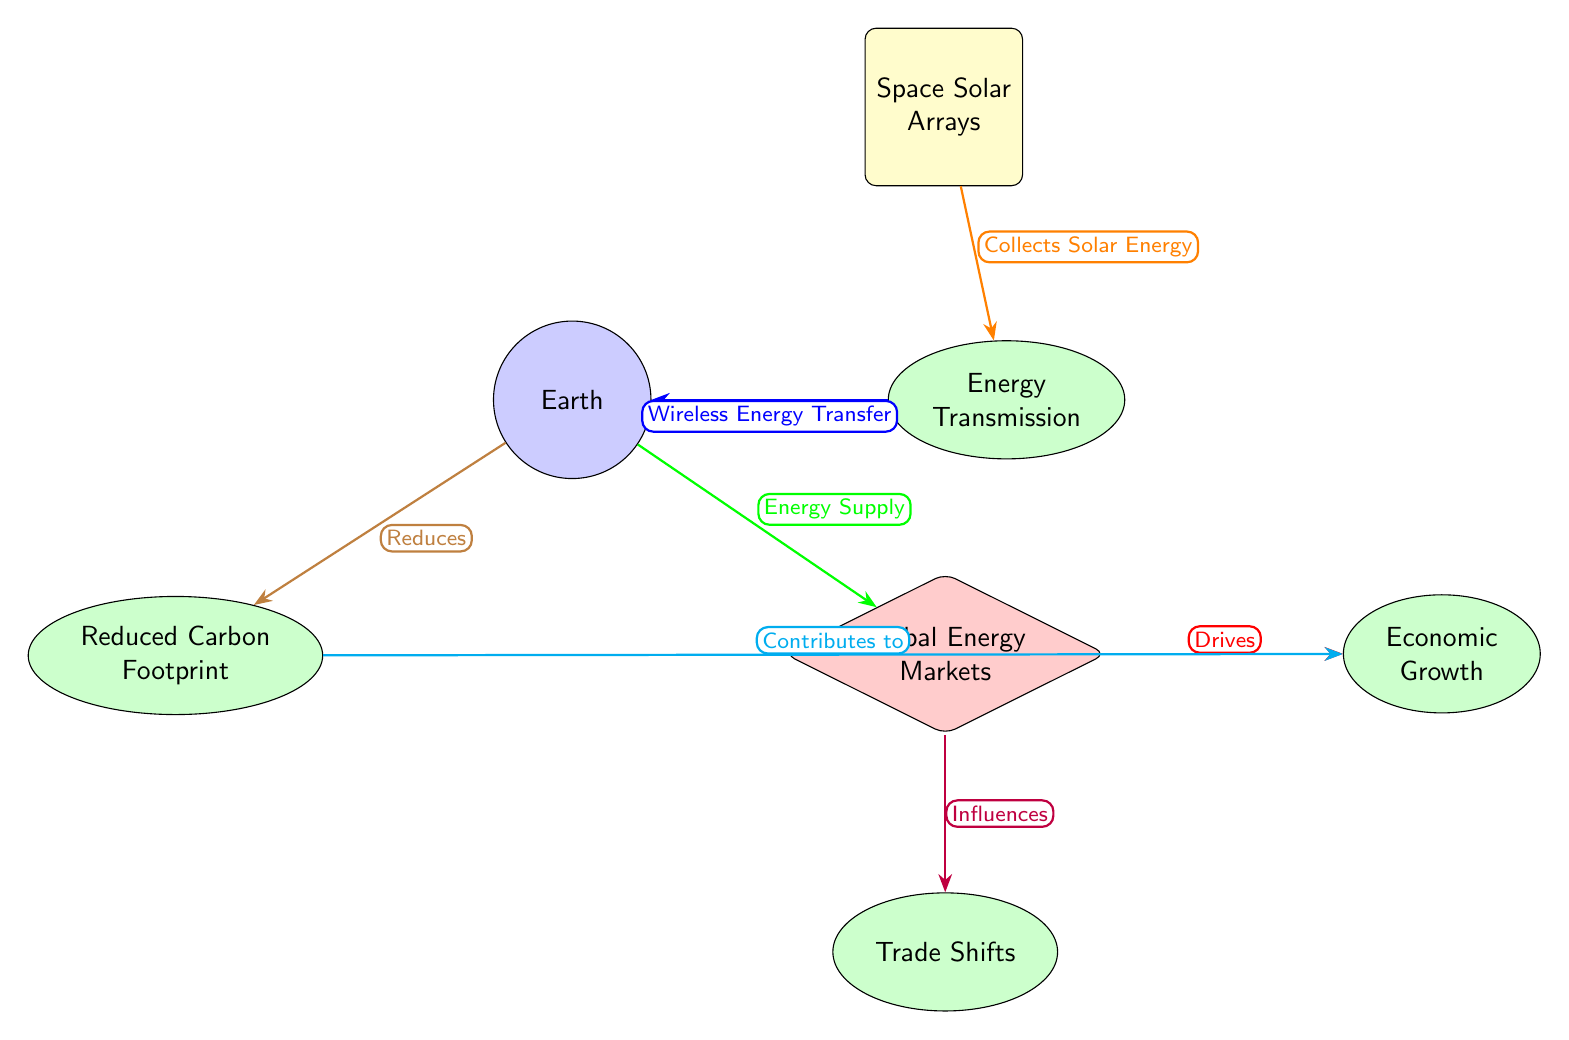What is the main source of energy in the diagram? The node labeled "Space Solar Arrays" indicates the main source of energy being collected in the diagram.
Answer: Space Solar Arrays How many concepts are identified in the diagram? There are four nodes labeled as concepts: Energy Transmission, Economic Growth, Trade Shifts, and Reduced Carbon Footprint. Thus, the count is four.
Answer: 4 Which node directly influences Economic Growth? The node "Global Energy Markets" has an arrow pointing towards "Economic Growth," indicating a direct influence from the markets on economic growth.
Answer: Global Energy Markets What type of energy transfer is depicted from Energy Transmission to Earth? The diagram labels this connection as "Wireless Energy Transfer." This denotes the method by which energy is conveyed to Earth.
Answer: Wireless Energy Transfer What is the relationship between Reduced Carbon Footprint and Economic Growth? The diagram shows an arrow from "Reduced Carbon Footprint" to "Economic Growth," indicating that a reduced carbon footprint contributes to economic growth.
Answer: Contributes to How does Global Energy Markets influence Trade Shifts? An arrow is directed from "Global Energy Markets" to "Trade Shifts," suggesting that market dynamics likely lead to shifts in trade practices or agreements.
Answer: Influences 